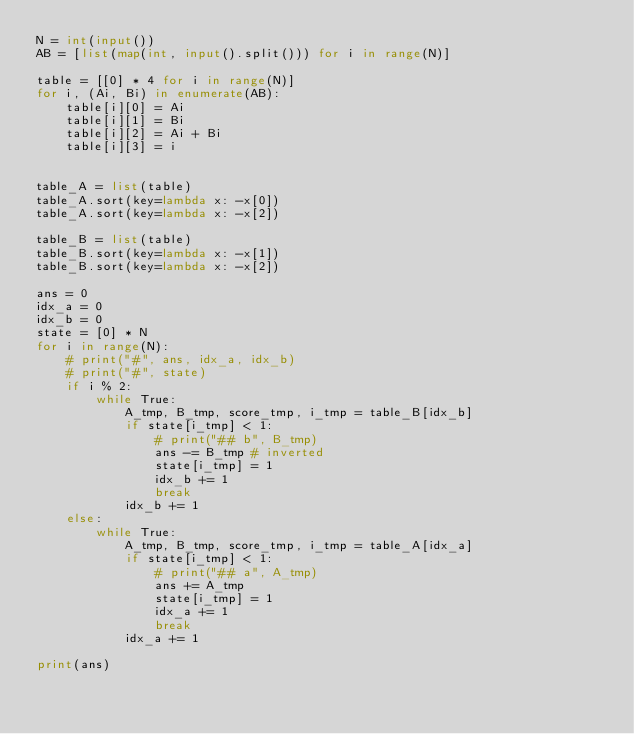Convert code to text. <code><loc_0><loc_0><loc_500><loc_500><_Python_>N = int(input())
AB = [list(map(int, input().split())) for i in range(N)]

table = [[0] * 4 for i in range(N)]
for i, (Ai, Bi) in enumerate(AB):
    table[i][0] = Ai
    table[i][1] = Bi 
    table[i][2] = Ai + Bi
    table[i][3] = i

    
table_A = list(table)
table_A.sort(key=lambda x: -x[0])
table_A.sort(key=lambda x: -x[2])

table_B = list(table)
table_B.sort(key=lambda x: -x[1])
table_B.sort(key=lambda x: -x[2])

ans = 0
idx_a = 0
idx_b = 0
state = [0] * N
for i in range(N):
    # print("#", ans, idx_a, idx_b)
    # print("#", state)
    if i % 2:
        while True:
            A_tmp, B_tmp, score_tmp, i_tmp = table_B[idx_b]
            if state[i_tmp] < 1:
                # print("## b", B_tmp)
                ans -= B_tmp # inverted
                state[i_tmp] = 1
                idx_b += 1
                break
            idx_b += 1
    else:
        while True:
            A_tmp, B_tmp, score_tmp, i_tmp = table_A[idx_a]
            if state[i_tmp] < 1:
                # print("## a", A_tmp)
                ans += A_tmp
                state[i_tmp] = 1
                idx_a += 1
                break
            idx_a += 1

print(ans)</code> 